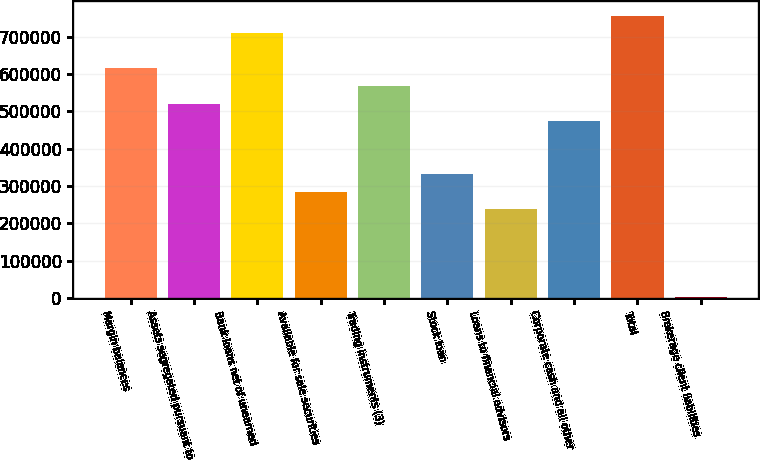Convert chart to OTSL. <chart><loc_0><loc_0><loc_500><loc_500><bar_chart><fcel>Margin balances<fcel>Assets segregated pursuant to<fcel>Bank loans net of unearned<fcel>Available for sale securities<fcel>Trading instruments (3)<fcel>Stock loan<fcel>Loans to financial advisors<fcel>Corporate cash and all other<fcel>Total<fcel>Brokerage client liabilities<nl><fcel>615064<fcel>520754<fcel>709374<fcel>284979<fcel>567909<fcel>332134<fcel>237824<fcel>473599<fcel>756529<fcel>2049<nl></chart> 